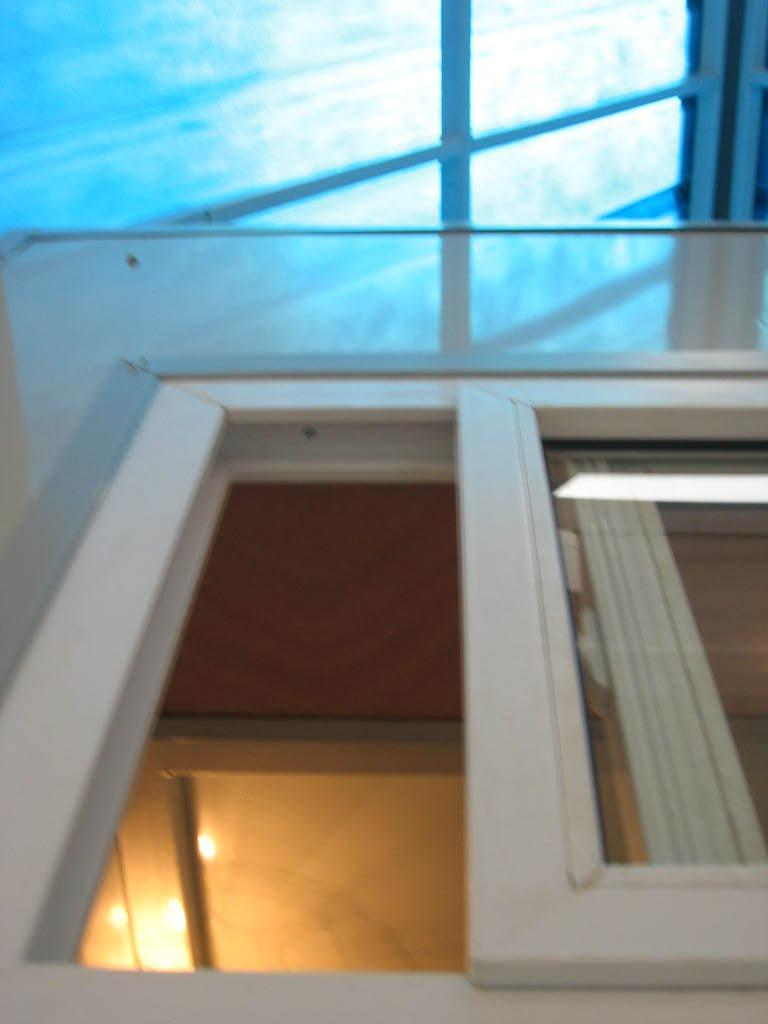What can be seen in the image that provides a view of the outdoors? There is a window in the image that provides a view of the outdoors. What type of window treatment is present in the image? The window has curtains. What can be seen inside the room in the image? There are lights visible in the image. What is visible in the background of the image? The sky is visible in the background of the image. Can you tell me which vegetable is being used as a prop by the actor in the image? There is no actor or vegetable present in the image; it features a window with curtains, lights, and a view of the sky. 